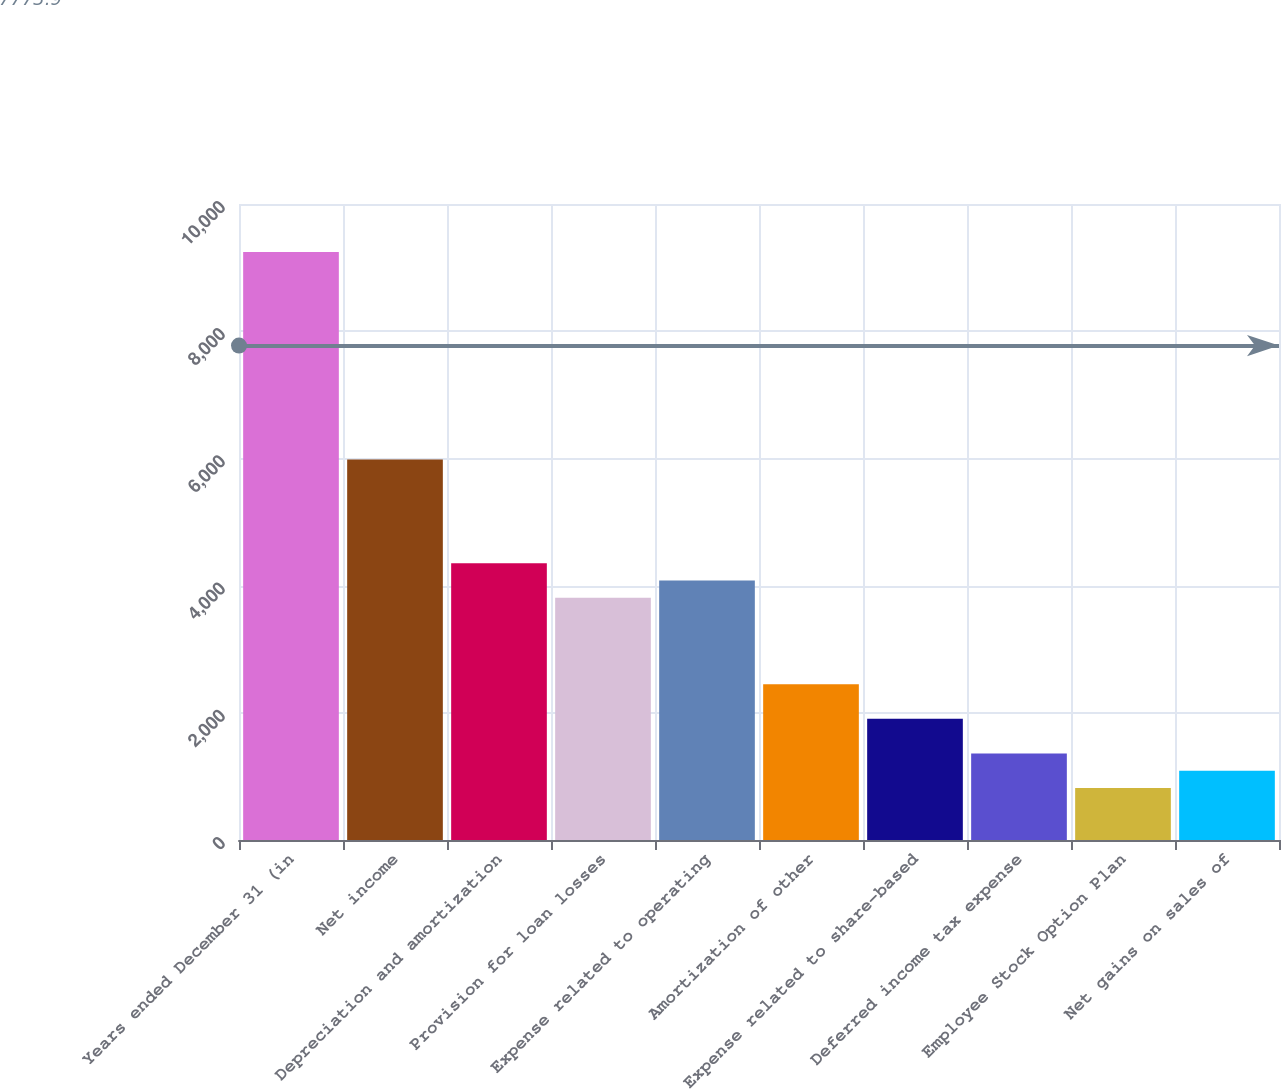Convert chart. <chart><loc_0><loc_0><loc_500><loc_500><bar_chart><fcel>Years ended December 31 (in<fcel>Net income<fcel>Depreciation and amortization<fcel>Provision for loan losses<fcel>Expense related to operating<fcel>Amortization of other<fcel>Expense related to share-based<fcel>Deferred income tax expense<fcel>Employee Stock Option Plan<fcel>Net gains on sales of<nl><fcel>9246.58<fcel>5983.54<fcel>4352.02<fcel>3808.18<fcel>4080.1<fcel>2448.58<fcel>1904.74<fcel>1360.9<fcel>817.06<fcel>1088.98<nl></chart> 